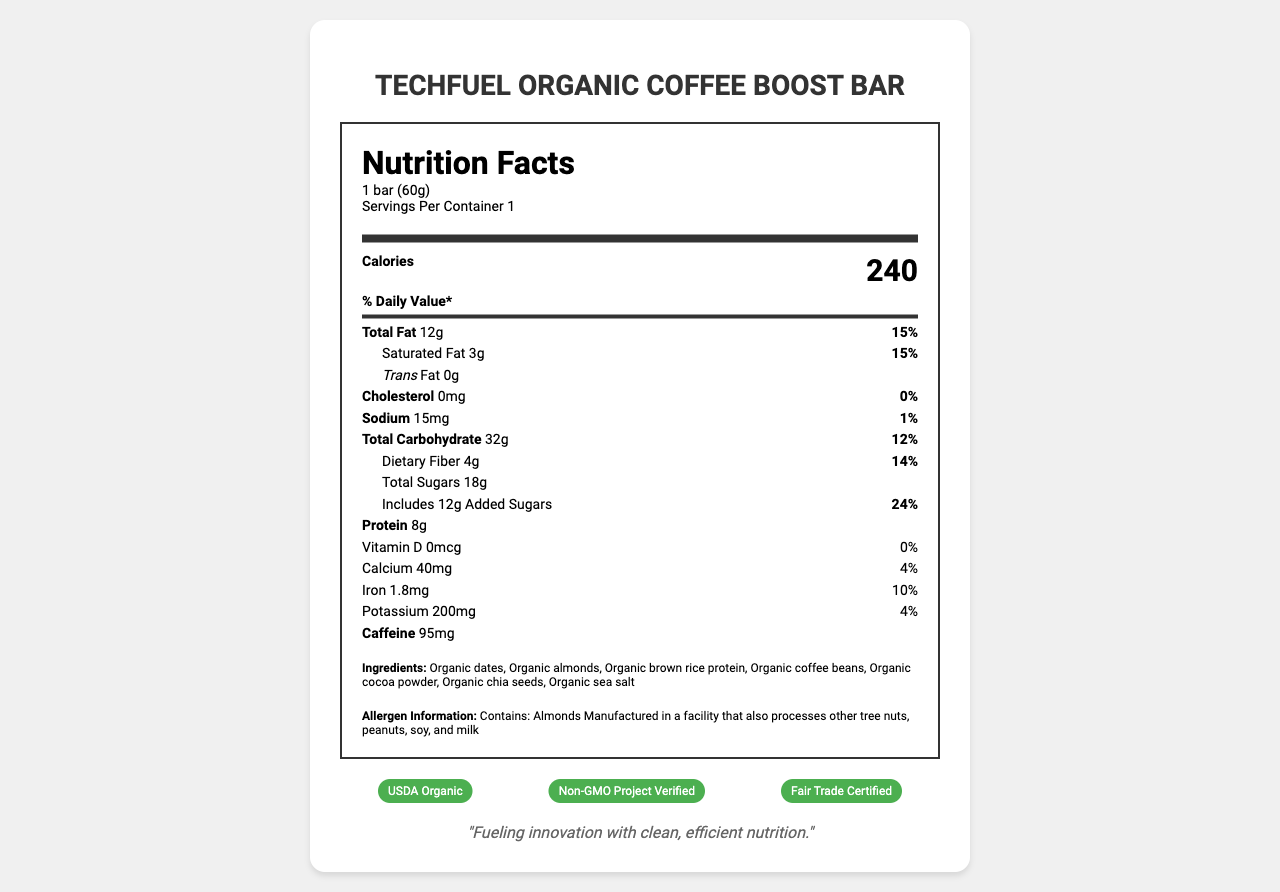what is the serving size? The serving size is explicitly stated as "1 bar (60g)" in the nutrition label.
Answer: 1 bar (60g) how many calories are in one serving? The nutrition label indicates there are 240 calories per serving.
Answer: 240 what is the total amount of fat in the bar? The total fat content is listed as "12g" on the nutrition label.
Answer: 12g how many grams of dietary fiber does the bar contain? The dietary fiber content is 4g as stated on the nutrition label.
Answer: 4g what percentage of the daily value of calcium does this bar provide? The daily value percentage for calcium is stated as 4% on the nutrition label.
Answer: 4% which of the following certifications does the TechFuel Organic Coffee Boost Bar have? A. USDA Organic B. Non-GMO Project Verified C. Gluten-Free D. All of the above The certifications listed under the nutrition facts include USDA Organic, Non-GMO Project Verified, and several special features including gluten-free, so D is the correct answer.
Answer: D what is the amount of added sugars in one serving? The added sugars are clearly shown as 12g on the nutrition label.
Answer: 12g how much caffeine does the bar contain? The caffeine content is specified as 95mg in the document.
Answer: 95mg does the bar contain any cholesterol? The nutrition label shows the cholesterol amount as "0mg," indicating there is no cholesterol in the bar.
Answer: No is the bar gluten-free? Under the special features, it is mentioned that the bar is gluten-free.
Answer: Yes how many grams of saturated fat are in the bar? The label states that the saturated fat content is 3g.
Answer: 3g summarize the main features and nutritional information of the TechFuel Organic Coffee Boost Bar. This answer summarizes the key nutritional information, certifications, and special features of the product as described in the document.
Answer: The TechFuel Organic Coffee Boost Bar is an organic, locally-sourced energy bar containing 240 calories per serving, 12g of total fat (including 3g of saturated fat), 32g of carbohydrates (4g dietary fiber, 18g total sugars including 12g added sugars), 8g of protein, and 95mg of caffeine. It is certified USDA Organic, Non-GMO Project Verified, Fair Trade Certified, gluten-free, vegan, and contains no artificial flavors or preservatives. The bar has a compostable wrapper and is manufactured in Palo Alto, CA. which company manufactures the TechFuel Organic Coffee Boost Bar? The document states that the bar is manufactured by TechFuel Foods, Inc.
Answer: TechFuel Foods, Inc. what is the daily value percentage of dietary fiber in this bar? The nutrition label shows that the dietary fiber content makes up 14% of the daily value.
Answer: 14% what is the amount of iron per serving? A. 2.5mg B. 1.8mg C. 3.0mg D. 0.7mg The iron content is indicated as 1.8mg on the nutrition label, so the correct answer is B.
Answer: B what is the company’s mission statement? The mission statement is explicitly stated at the bottom of the document as "Fueling innovation with clean, efficient nutrition."
Answer: Fueling innovation with clean, efficient nutrition. how much sodium does one serving of the bar contain? The amount of sodium per serving is listed as 15mg on the nutrition label.
Answer: 15mg what are the possible allergens listed for this bar? The allergen information is clearly stated under the ingredients section, listing almonds and the other potential allergens processed in the facility.
Answer: Contains: Almonds, Manufactured in a facility that also processes other tree nuts, peanuts, soy, and milk can you determine the exact recipe or proportions of ingredients in the bar? The document lists the ingredients but does not provide the exact proportions or recipe details.
Answer: Not enough information what are the benefits of the compostable wrapper mentioned in the special features? The document mentions that the wrapper is compostable, but it does not provide specific benefits or details about the wrapper.
Answer: Cannot be determined 